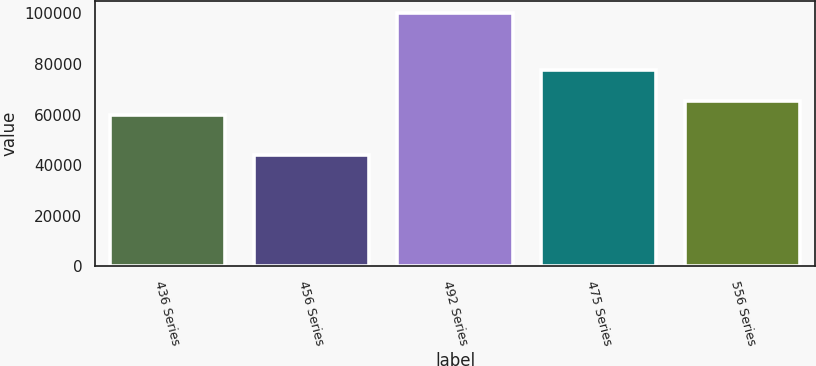Convert chart. <chart><loc_0><loc_0><loc_500><loc_500><bar_chart><fcel>436 Series<fcel>456 Series<fcel>492 Series<fcel>475 Series<fcel>556 Series<nl><fcel>59920<fcel>43887<fcel>100000<fcel>77798<fcel>65531.3<nl></chart> 